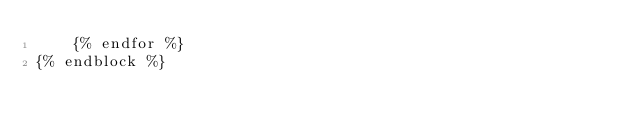<code> <loc_0><loc_0><loc_500><loc_500><_HTML_>    {% endfor %}
{% endblock %}
</code> 